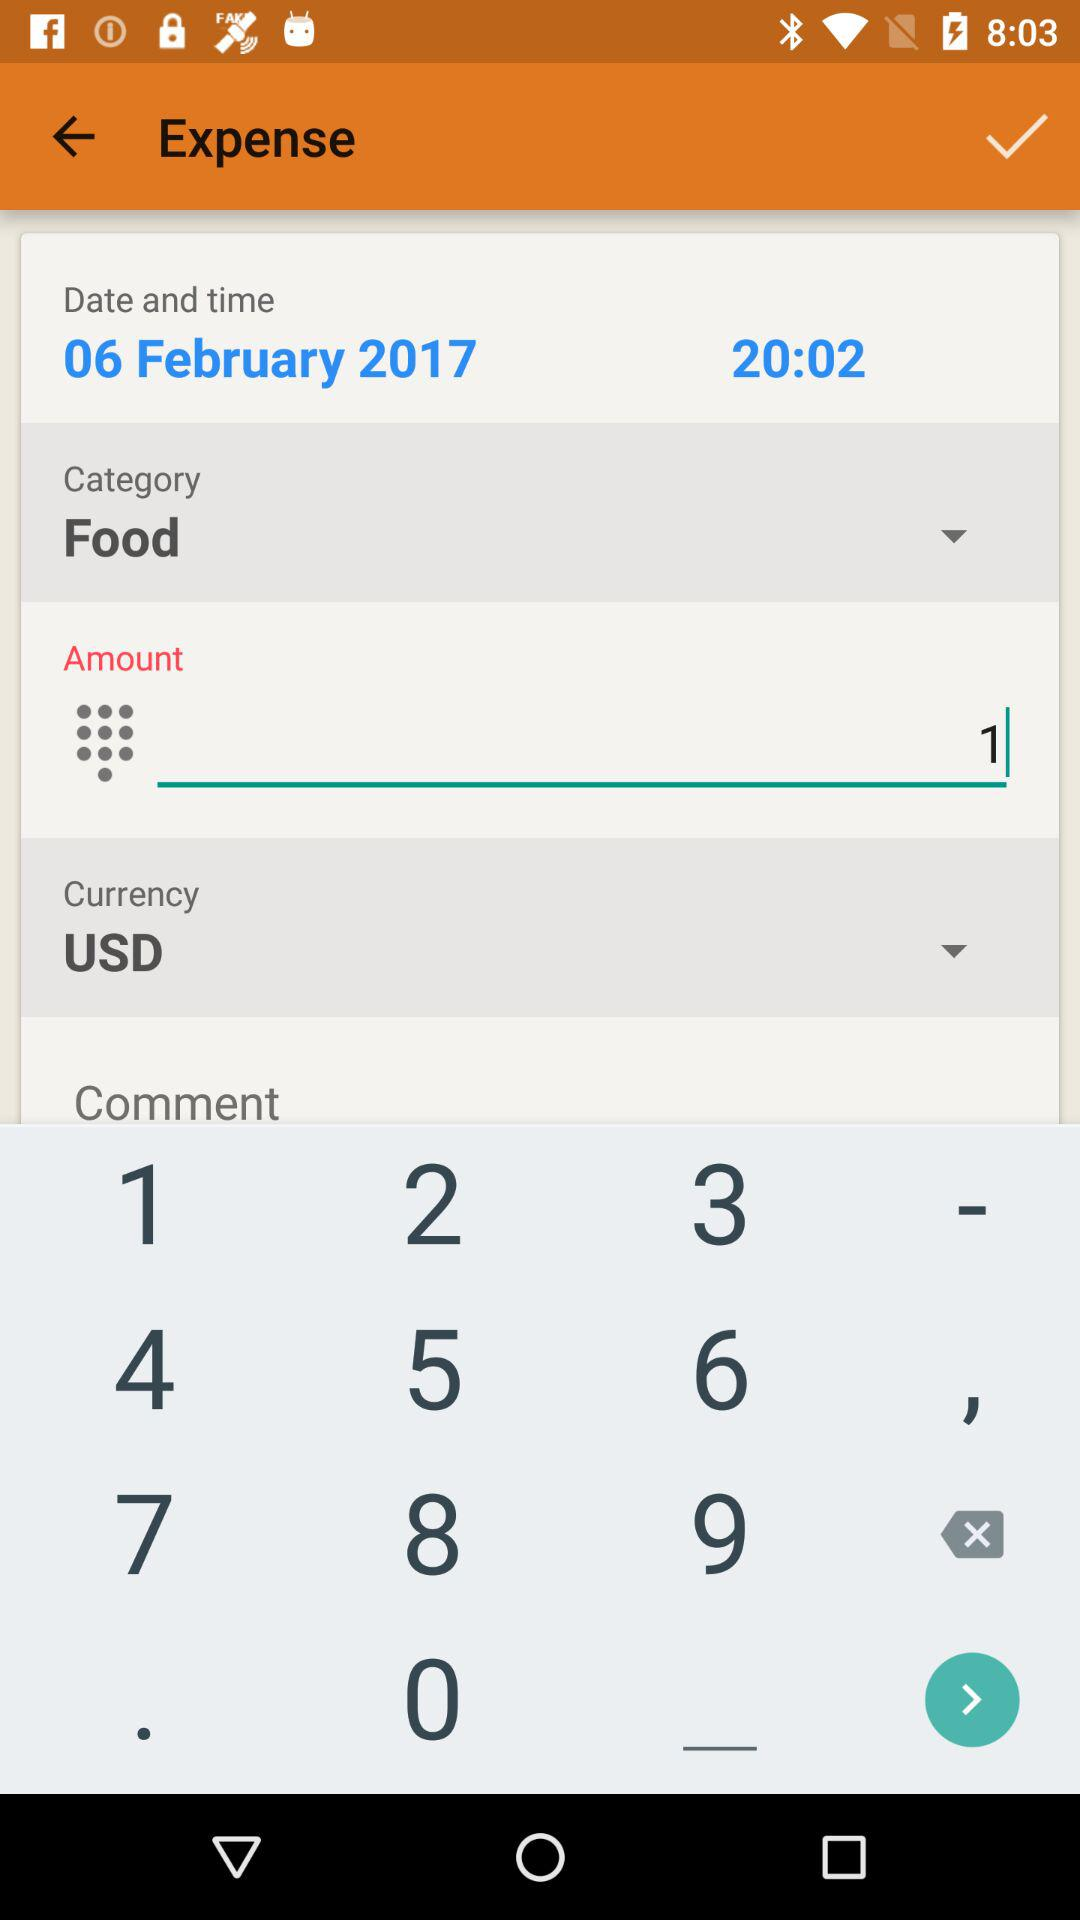What is the category of the expense?
Answer the question using a single word or phrase. Food 